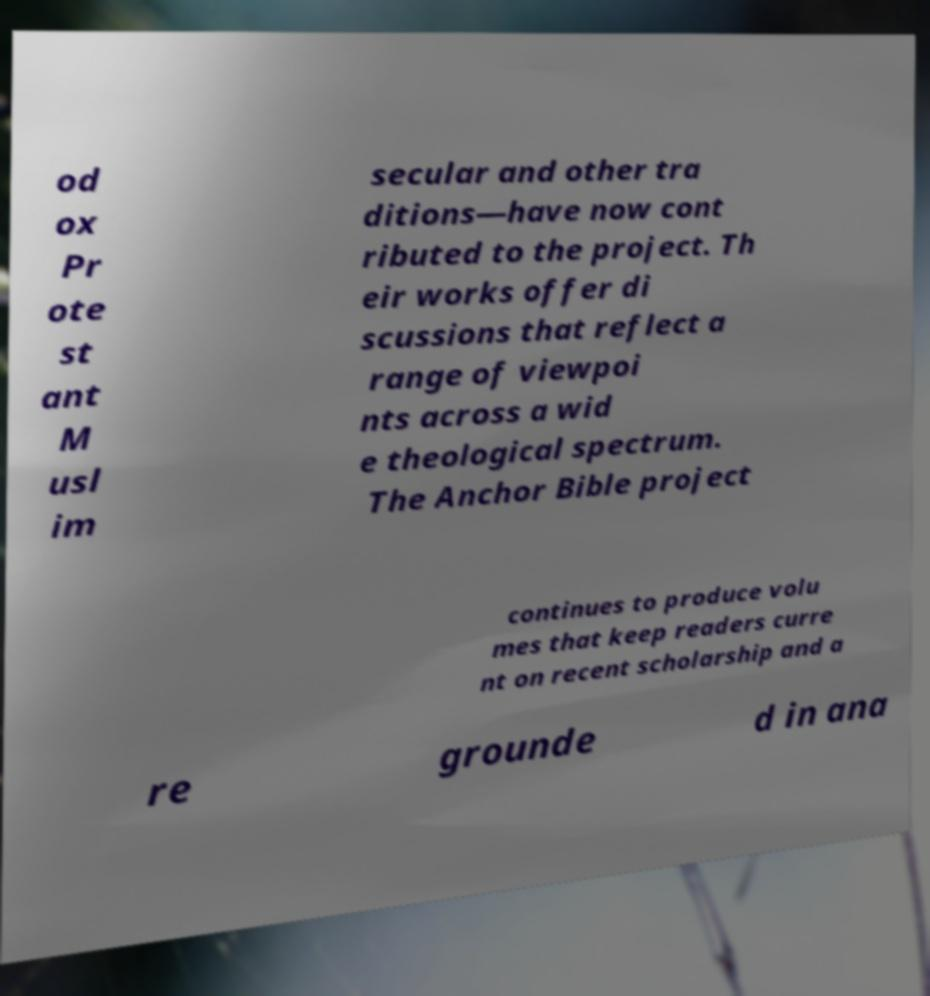Can you accurately transcribe the text from the provided image for me? od ox Pr ote st ant M usl im secular and other tra ditions—have now cont ributed to the project. Th eir works offer di scussions that reflect a range of viewpoi nts across a wid e theological spectrum. The Anchor Bible project continues to produce volu mes that keep readers curre nt on recent scholarship and a re grounde d in ana 